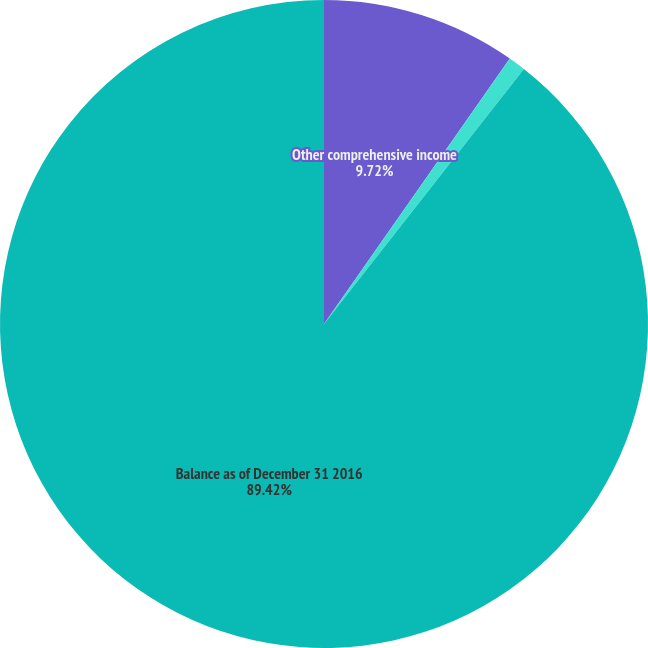<chart> <loc_0><loc_0><loc_500><loc_500><pie_chart><fcel>Other comprehensive income<fcel>Net current-period other<fcel>Balance as of December 31 2016<nl><fcel>9.72%<fcel>0.86%<fcel>89.42%<nl></chart> 